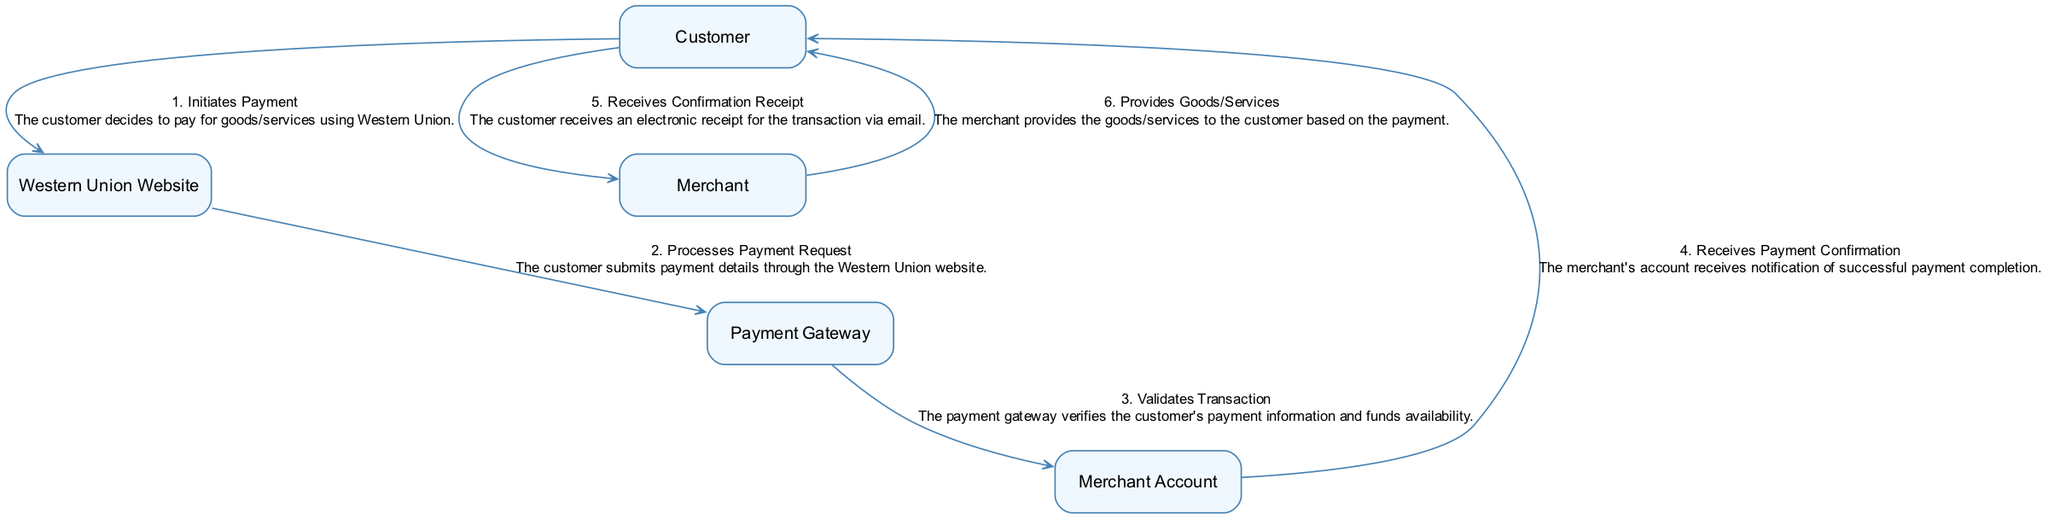What entity initiates the payment process? The diagram states that the "Customer" is the entity that initiates the payment process by deciding to pay for goods/services using Western Union.
Answer: Customer How many major actions are involved in the payment process? By examining the diagram, I can identify six major actions that occur in the payment process from the Customer to the Merchant while utilizing Western Union services.
Answer: Six What is the first action taken in the sequence? According to the diagram, the first action taken in the sequence is "Initiates Payment," where the Customer decides to pay for the goods/services.
Answer: Initiates Payment What action does the Payment Gateway perform? The diagram shows that the Payment Gateway action is to "Validates Transaction," meaning it verifies the customer's payment information and funds availability.
Answer: Validates Transaction What does the Customer receive after the payment confirmation? Following the sequence, the Customer receives an electronic receipt for the transaction via email as a confirmation.
Answer: Confirmation Receipt Which entity provides the goods/services to the Customer? The diagram indicates that the "Merchant" is responsible for providing the goods/services to the Customer based on the payment.
Answer: Merchant What happens after the Payment Gateway validates the transaction? The sequence describes that once the Payment Gateway validates the transaction, the "Merchant Account" receives a payment confirmation notification.
Answer: Receives Payment Confirmation What is the relationship between the Customer and the Merchant? The diagram illustrates that the Customer interacts with the Merchant in a transactional relationship wherein the Merchant provides goods/services in exchange for payment.
Answer: Transactional Relationship How is the flow of actions structured in the diagram? The actions are structured in a linear sequence that progresses from the Customer initiating the payment up to the Merchant providing the goods/services, creating a straightforward flow from start to finish.
Answer: Linear Sequence 